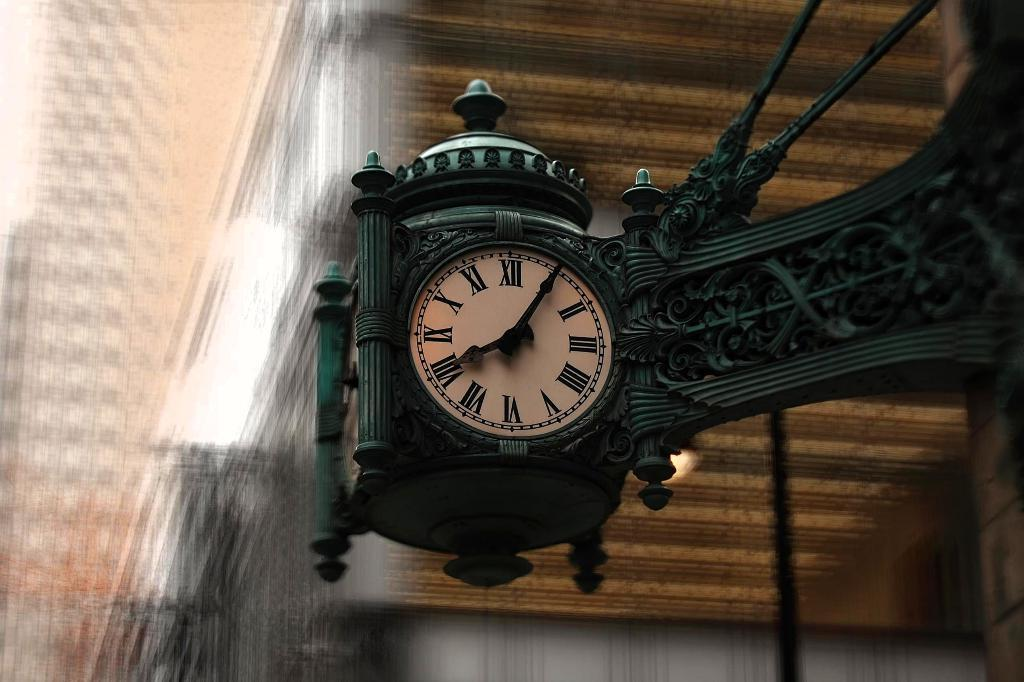<image>
Give a short and clear explanation of the subsequent image. The intricately designed clock says that the time is five minutes after eight. 